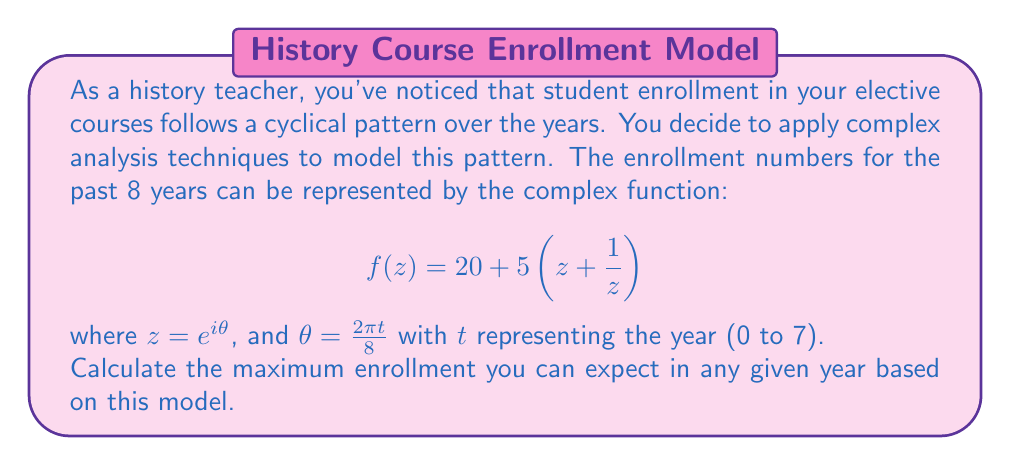What is the answer to this math problem? To solve this problem, we'll follow these steps:

1) First, let's expand the given function:
   $$f(z) = 20 + 5(z + \frac{1}{z}) = 20 + 5z + \frac{5}{z}$$

2) We know that $z = e^{i\theta} = \cos\theta + i\sin\theta$, and $\frac{1}{z} = e^{-i\theta} = \cos\theta - i\sin\theta$

3) Substituting these into our function:
   $$f(z) = 20 + 5(\cos\theta + i\sin\theta) + 5(\cos\theta - i\sin\theta)$$

4) Simplifying:
   $$f(z) = 20 + 10\cos\theta$$

5) This is a real-valued function, oscillating around 20 with amplitude 10.

6) The maximum value will occur when $\cos\theta = 1$, which happens when $\theta = 0, 2\pi, 4\pi,$ etc.

7) The maximum value is therefore:
   $$f_{max} = 20 + 10(1) = 30$$

Thus, the maximum enrollment you can expect in any given year is 30 students.
Answer: 30 students 